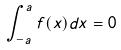<formula> <loc_0><loc_0><loc_500><loc_500>\int _ { - a } ^ { a } f ( x ) d x = 0</formula> 